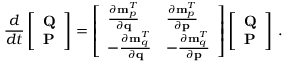Convert formula to latex. <formula><loc_0><loc_0><loc_500><loc_500>\frac { d } { d t } \left [ \begin{array} { l } { Q } \\ { P } \end{array} \right ] = \left [ \begin{array} { l l } { \frac { \partial { m } _ { p } ^ { T } } { \partial { q } } } & { \frac { \partial { m } _ { p } ^ { T } } { \partial { p } } } \\ { - \frac { \partial { m } _ { q } ^ { T } } { \partial { q } } } & { - \frac { \partial { m } _ { q } ^ { T } } { \partial { p } } } \end{array} \right ] \left [ \begin{array} { l } { Q } \\ { P } \end{array} \right ] \, .</formula> 